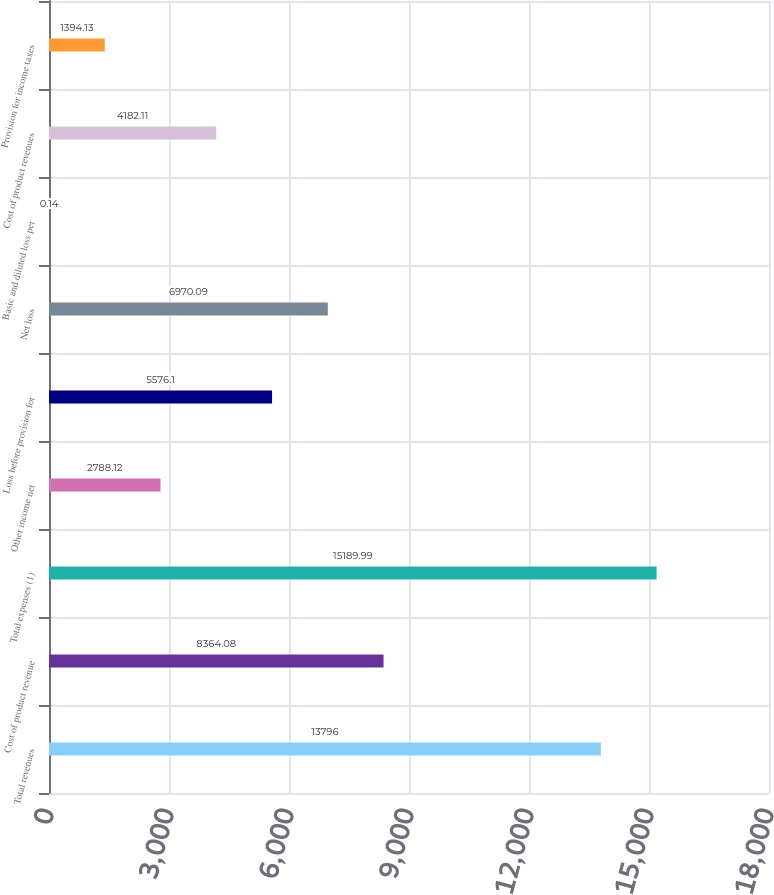<chart> <loc_0><loc_0><loc_500><loc_500><bar_chart><fcel>Total revenues<fcel>Cost of product revenue<fcel>Total expenses (1)<fcel>Other income net<fcel>Loss before provision for<fcel>Net loss<fcel>Basic and diluted loss per<fcel>Cost of product revenues<fcel>Provision for income taxes<nl><fcel>13796<fcel>8364.08<fcel>15190<fcel>2788.12<fcel>5576.1<fcel>6970.09<fcel>0.14<fcel>4182.11<fcel>1394.13<nl></chart> 